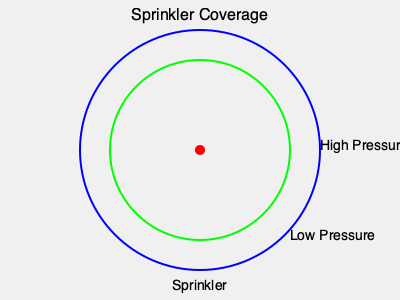Your backyard has a circular shape with a radius of 40 feet. You're considering two sprinkler nozzle types: one that covers a 30-foot radius at low pressure, and another that covers a 40-foot radius at high pressure. What percentage of your backyard would the low-pressure nozzle cover compared to the high-pressure nozzle? To solve this problem, we'll follow these steps:

1. Calculate the area of the entire backyard (high-pressure coverage):
   $A_{high} = \pi r^2 = \pi (40 \text{ ft})^2 = 1600\pi \text{ sq ft}$

2. Calculate the area covered by the low-pressure nozzle:
   $A_{low} = \pi r^2 = \pi (30 \text{ ft})^2 = 900\pi \text{ sq ft}$

3. Calculate the percentage of coverage:
   $$\text{Percentage} = \frac{A_{low}}{A_{high}} \times 100\% = \frac{900\pi}{1600\pi} \times 100\% = \frac{900}{1600} \times 100\% = 0.5625 \times 100\% = 56.25\%$$

Therefore, the low-pressure nozzle would cover 56.25% of the area that the high-pressure nozzle covers.
Answer: 56.25% 